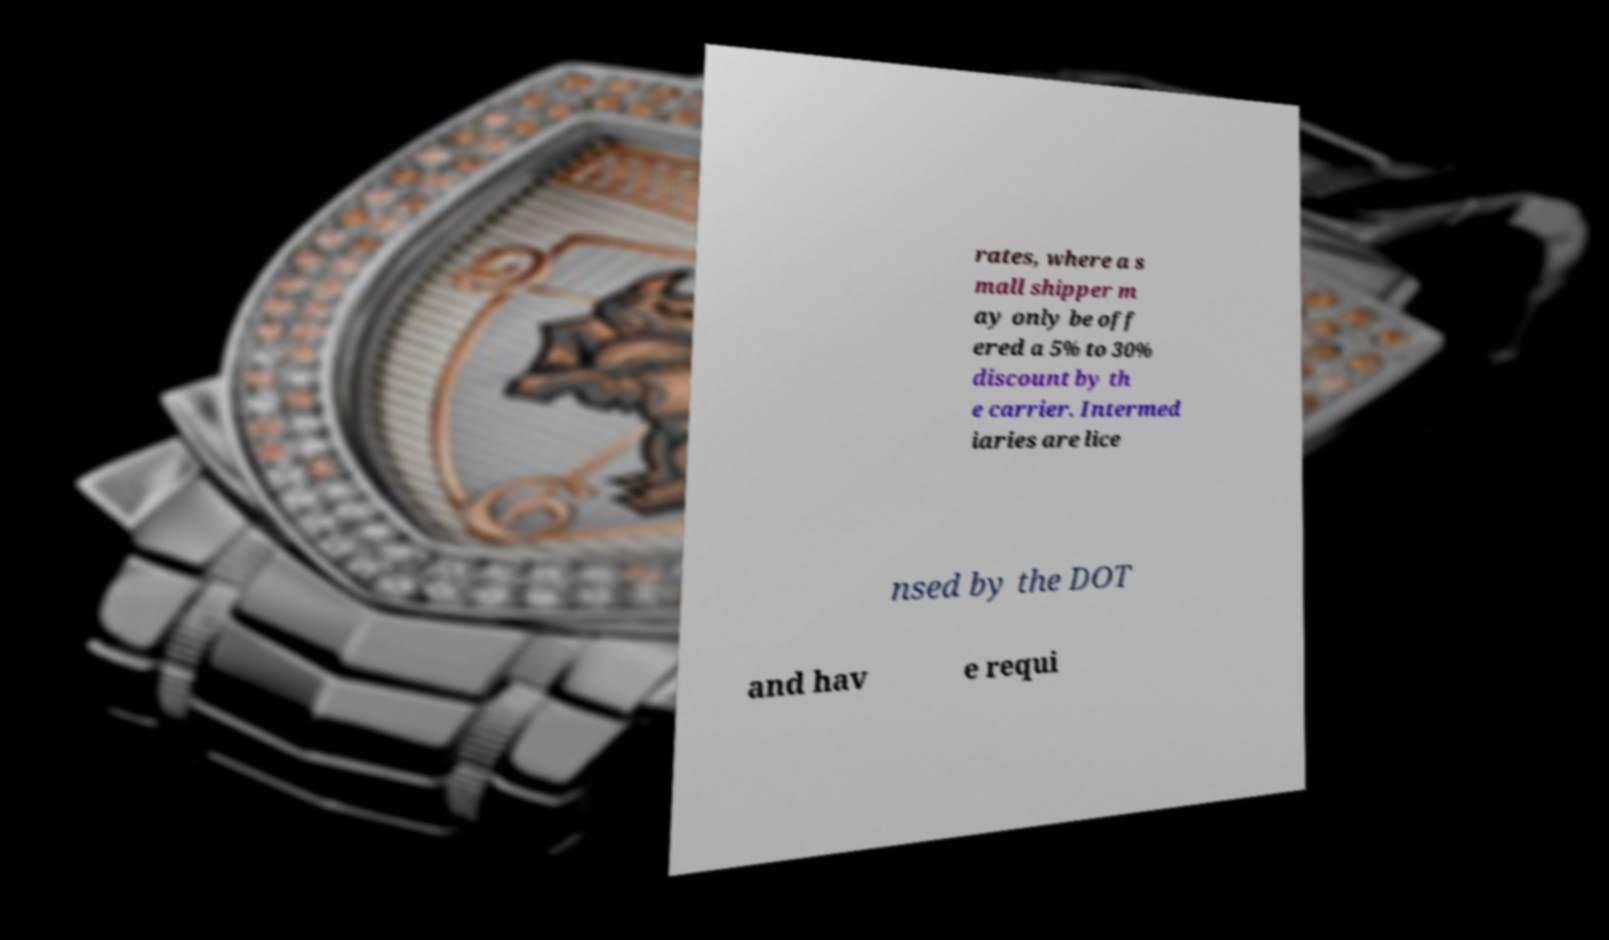I need the written content from this picture converted into text. Can you do that? rates, where a s mall shipper m ay only be off ered a 5% to 30% discount by th e carrier. Intermed iaries are lice nsed by the DOT and hav e requi 